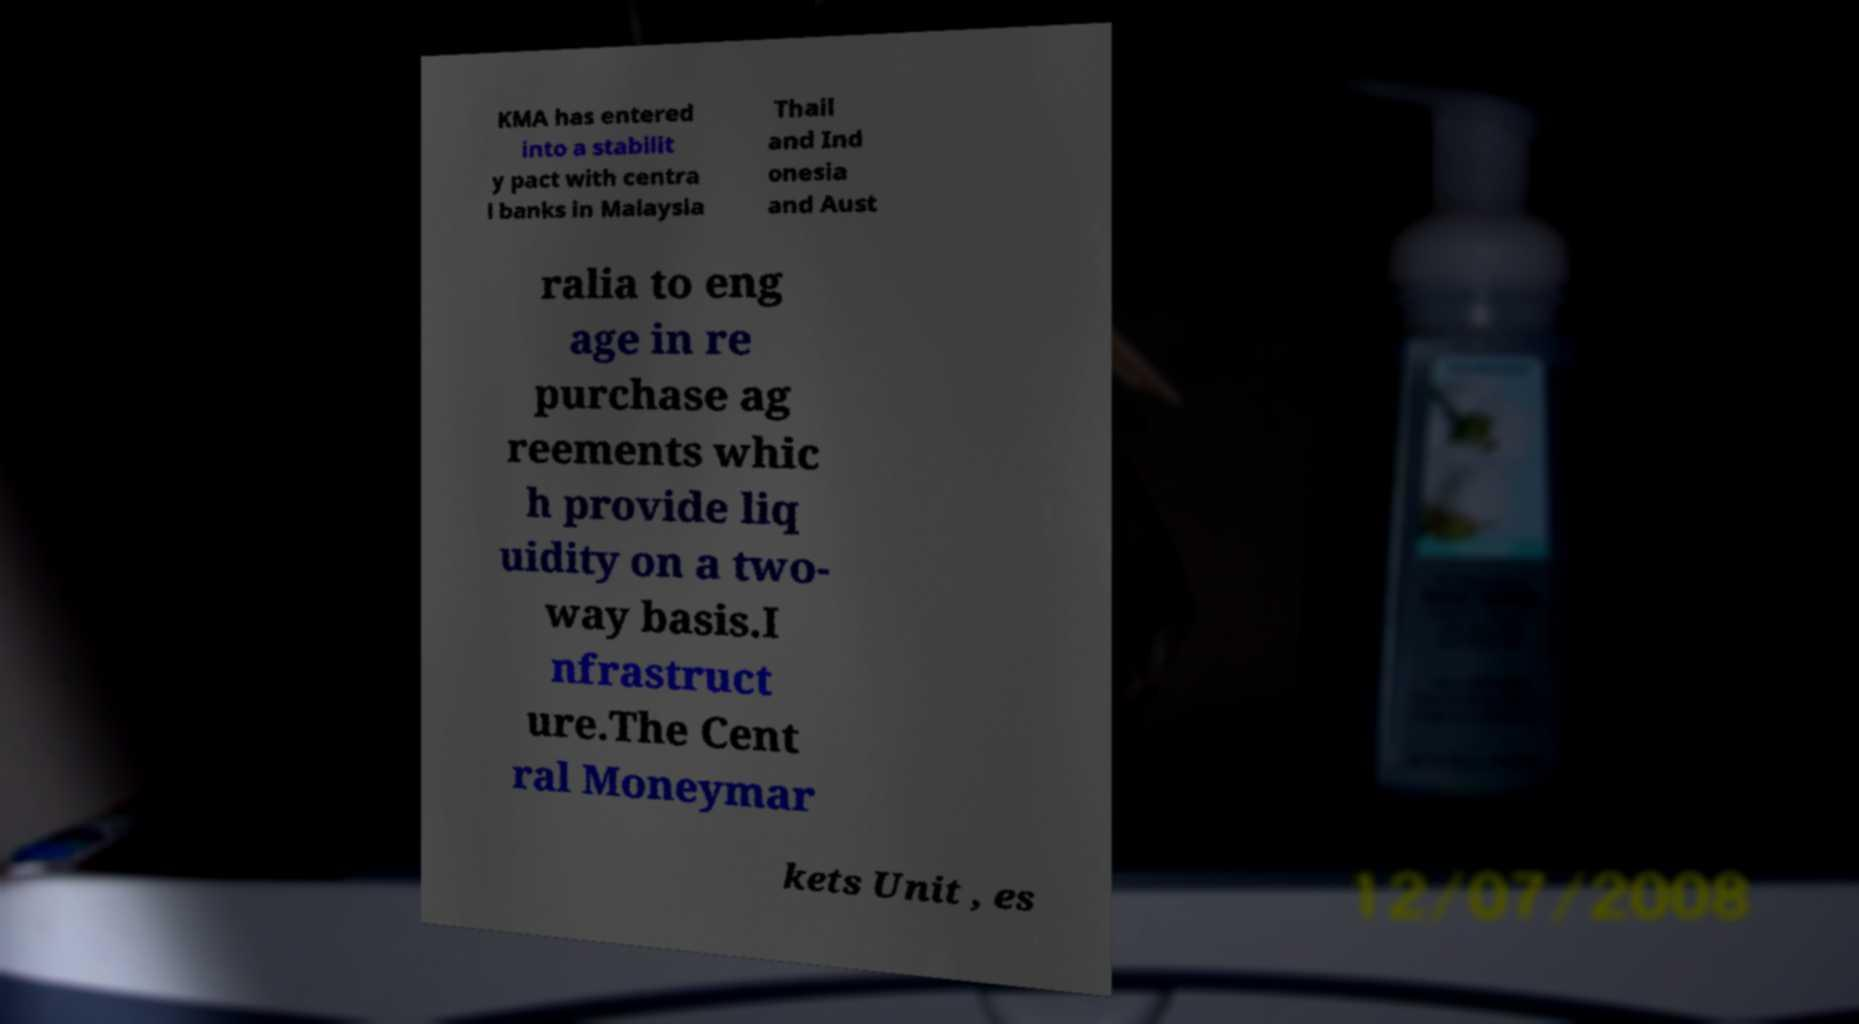Can you read and provide the text displayed in the image?This photo seems to have some interesting text. Can you extract and type it out for me? KMA has entered into a stabilit y pact with centra l banks in Malaysia Thail and Ind onesia and Aust ralia to eng age in re purchase ag reements whic h provide liq uidity on a two- way basis.I nfrastruct ure.The Cent ral Moneymar kets Unit , es 